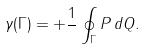Convert formula to latex. <formula><loc_0><loc_0><loc_500><loc_500>\gamma ( \Gamma ) = + \frac { 1 } { } \oint _ { \Gamma } P \, d Q .</formula> 